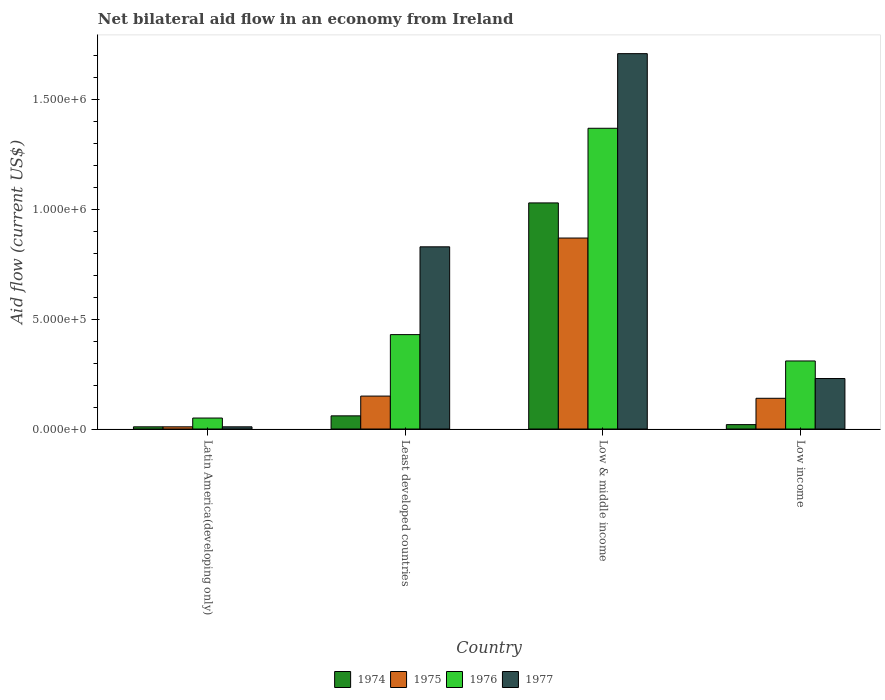Are the number of bars on each tick of the X-axis equal?
Your response must be concise. Yes. How many bars are there on the 2nd tick from the left?
Make the answer very short. 4. How many bars are there on the 1st tick from the right?
Your answer should be very brief. 4. Across all countries, what is the maximum net bilateral aid flow in 1976?
Provide a short and direct response. 1.37e+06. In which country was the net bilateral aid flow in 1977 maximum?
Provide a short and direct response. Low & middle income. In which country was the net bilateral aid flow in 1976 minimum?
Ensure brevity in your answer.  Latin America(developing only). What is the total net bilateral aid flow in 1976 in the graph?
Make the answer very short. 2.16e+06. What is the difference between the net bilateral aid flow in 1974 in Latin America(developing only) and that in Low income?
Offer a terse response. -10000. What is the average net bilateral aid flow in 1977 per country?
Provide a short and direct response. 6.95e+05. What is the ratio of the net bilateral aid flow in 1976 in Least developed countries to that in Low & middle income?
Your response must be concise. 0.31. Is the difference between the net bilateral aid flow in 1977 in Low & middle income and Low income greater than the difference between the net bilateral aid flow in 1976 in Low & middle income and Low income?
Ensure brevity in your answer.  Yes. What is the difference between the highest and the second highest net bilateral aid flow in 1976?
Your answer should be compact. 9.40e+05. What is the difference between the highest and the lowest net bilateral aid flow in 1975?
Provide a succinct answer. 8.60e+05. In how many countries, is the net bilateral aid flow in 1975 greater than the average net bilateral aid flow in 1975 taken over all countries?
Give a very brief answer. 1. Is the sum of the net bilateral aid flow in 1974 in Latin America(developing only) and Low & middle income greater than the maximum net bilateral aid flow in 1976 across all countries?
Offer a very short reply. No. What does the 4th bar from the left in Low & middle income represents?
Make the answer very short. 1977. What does the 4th bar from the right in Least developed countries represents?
Offer a terse response. 1974. Is it the case that in every country, the sum of the net bilateral aid flow in 1975 and net bilateral aid flow in 1974 is greater than the net bilateral aid flow in 1976?
Your response must be concise. No. What is the difference between two consecutive major ticks on the Y-axis?
Your answer should be very brief. 5.00e+05. Are the values on the major ticks of Y-axis written in scientific E-notation?
Make the answer very short. Yes. Does the graph contain any zero values?
Give a very brief answer. No. How many legend labels are there?
Offer a very short reply. 4. How are the legend labels stacked?
Provide a short and direct response. Horizontal. What is the title of the graph?
Your response must be concise. Net bilateral aid flow in an economy from Ireland. What is the Aid flow (current US$) of 1974 in Latin America(developing only)?
Your answer should be very brief. 10000. What is the Aid flow (current US$) of 1976 in Least developed countries?
Offer a very short reply. 4.30e+05. What is the Aid flow (current US$) of 1977 in Least developed countries?
Offer a terse response. 8.30e+05. What is the Aid flow (current US$) of 1974 in Low & middle income?
Offer a terse response. 1.03e+06. What is the Aid flow (current US$) in 1975 in Low & middle income?
Offer a very short reply. 8.70e+05. What is the Aid flow (current US$) in 1976 in Low & middle income?
Your response must be concise. 1.37e+06. What is the Aid flow (current US$) of 1977 in Low & middle income?
Your answer should be compact. 1.71e+06. What is the Aid flow (current US$) in 1974 in Low income?
Offer a very short reply. 2.00e+04. What is the Aid flow (current US$) in 1975 in Low income?
Your response must be concise. 1.40e+05. Across all countries, what is the maximum Aid flow (current US$) of 1974?
Offer a terse response. 1.03e+06. Across all countries, what is the maximum Aid flow (current US$) of 1975?
Provide a short and direct response. 8.70e+05. Across all countries, what is the maximum Aid flow (current US$) in 1976?
Your answer should be compact. 1.37e+06. Across all countries, what is the maximum Aid flow (current US$) in 1977?
Keep it short and to the point. 1.71e+06. Across all countries, what is the minimum Aid flow (current US$) in 1975?
Your response must be concise. 10000. What is the total Aid flow (current US$) in 1974 in the graph?
Offer a very short reply. 1.12e+06. What is the total Aid flow (current US$) of 1975 in the graph?
Offer a terse response. 1.17e+06. What is the total Aid flow (current US$) in 1976 in the graph?
Your answer should be compact. 2.16e+06. What is the total Aid flow (current US$) of 1977 in the graph?
Your answer should be very brief. 2.78e+06. What is the difference between the Aid flow (current US$) of 1975 in Latin America(developing only) and that in Least developed countries?
Offer a terse response. -1.40e+05. What is the difference between the Aid flow (current US$) of 1976 in Latin America(developing only) and that in Least developed countries?
Keep it short and to the point. -3.80e+05. What is the difference between the Aid flow (current US$) of 1977 in Latin America(developing only) and that in Least developed countries?
Offer a terse response. -8.20e+05. What is the difference between the Aid flow (current US$) in 1974 in Latin America(developing only) and that in Low & middle income?
Your answer should be very brief. -1.02e+06. What is the difference between the Aid flow (current US$) in 1975 in Latin America(developing only) and that in Low & middle income?
Ensure brevity in your answer.  -8.60e+05. What is the difference between the Aid flow (current US$) of 1976 in Latin America(developing only) and that in Low & middle income?
Your answer should be very brief. -1.32e+06. What is the difference between the Aid flow (current US$) in 1977 in Latin America(developing only) and that in Low & middle income?
Your response must be concise. -1.70e+06. What is the difference between the Aid flow (current US$) in 1975 in Latin America(developing only) and that in Low income?
Your response must be concise. -1.30e+05. What is the difference between the Aid flow (current US$) of 1976 in Latin America(developing only) and that in Low income?
Give a very brief answer. -2.60e+05. What is the difference between the Aid flow (current US$) in 1977 in Latin America(developing only) and that in Low income?
Offer a terse response. -2.20e+05. What is the difference between the Aid flow (current US$) in 1974 in Least developed countries and that in Low & middle income?
Your answer should be very brief. -9.70e+05. What is the difference between the Aid flow (current US$) in 1975 in Least developed countries and that in Low & middle income?
Your answer should be very brief. -7.20e+05. What is the difference between the Aid flow (current US$) in 1976 in Least developed countries and that in Low & middle income?
Give a very brief answer. -9.40e+05. What is the difference between the Aid flow (current US$) of 1977 in Least developed countries and that in Low & middle income?
Give a very brief answer. -8.80e+05. What is the difference between the Aid flow (current US$) of 1976 in Least developed countries and that in Low income?
Your answer should be compact. 1.20e+05. What is the difference between the Aid flow (current US$) of 1977 in Least developed countries and that in Low income?
Provide a succinct answer. 6.00e+05. What is the difference between the Aid flow (current US$) in 1974 in Low & middle income and that in Low income?
Your answer should be compact. 1.01e+06. What is the difference between the Aid flow (current US$) in 1975 in Low & middle income and that in Low income?
Offer a very short reply. 7.30e+05. What is the difference between the Aid flow (current US$) of 1976 in Low & middle income and that in Low income?
Provide a short and direct response. 1.06e+06. What is the difference between the Aid flow (current US$) of 1977 in Low & middle income and that in Low income?
Make the answer very short. 1.48e+06. What is the difference between the Aid flow (current US$) in 1974 in Latin America(developing only) and the Aid flow (current US$) in 1976 in Least developed countries?
Provide a short and direct response. -4.20e+05. What is the difference between the Aid flow (current US$) in 1974 in Latin America(developing only) and the Aid flow (current US$) in 1977 in Least developed countries?
Ensure brevity in your answer.  -8.20e+05. What is the difference between the Aid flow (current US$) of 1975 in Latin America(developing only) and the Aid flow (current US$) of 1976 in Least developed countries?
Keep it short and to the point. -4.20e+05. What is the difference between the Aid flow (current US$) of 1975 in Latin America(developing only) and the Aid flow (current US$) of 1977 in Least developed countries?
Provide a succinct answer. -8.20e+05. What is the difference between the Aid flow (current US$) in 1976 in Latin America(developing only) and the Aid flow (current US$) in 1977 in Least developed countries?
Make the answer very short. -7.80e+05. What is the difference between the Aid flow (current US$) of 1974 in Latin America(developing only) and the Aid flow (current US$) of 1975 in Low & middle income?
Your answer should be very brief. -8.60e+05. What is the difference between the Aid flow (current US$) in 1974 in Latin America(developing only) and the Aid flow (current US$) in 1976 in Low & middle income?
Give a very brief answer. -1.36e+06. What is the difference between the Aid flow (current US$) in 1974 in Latin America(developing only) and the Aid flow (current US$) in 1977 in Low & middle income?
Keep it short and to the point. -1.70e+06. What is the difference between the Aid flow (current US$) of 1975 in Latin America(developing only) and the Aid flow (current US$) of 1976 in Low & middle income?
Offer a very short reply. -1.36e+06. What is the difference between the Aid flow (current US$) in 1975 in Latin America(developing only) and the Aid flow (current US$) in 1977 in Low & middle income?
Ensure brevity in your answer.  -1.70e+06. What is the difference between the Aid flow (current US$) of 1976 in Latin America(developing only) and the Aid flow (current US$) of 1977 in Low & middle income?
Provide a short and direct response. -1.66e+06. What is the difference between the Aid flow (current US$) in 1974 in Latin America(developing only) and the Aid flow (current US$) in 1976 in Low income?
Make the answer very short. -3.00e+05. What is the difference between the Aid flow (current US$) in 1975 in Latin America(developing only) and the Aid flow (current US$) in 1977 in Low income?
Provide a succinct answer. -2.20e+05. What is the difference between the Aid flow (current US$) in 1976 in Latin America(developing only) and the Aid flow (current US$) in 1977 in Low income?
Provide a short and direct response. -1.80e+05. What is the difference between the Aid flow (current US$) in 1974 in Least developed countries and the Aid flow (current US$) in 1975 in Low & middle income?
Provide a short and direct response. -8.10e+05. What is the difference between the Aid flow (current US$) in 1974 in Least developed countries and the Aid flow (current US$) in 1976 in Low & middle income?
Keep it short and to the point. -1.31e+06. What is the difference between the Aid flow (current US$) in 1974 in Least developed countries and the Aid flow (current US$) in 1977 in Low & middle income?
Your answer should be compact. -1.65e+06. What is the difference between the Aid flow (current US$) in 1975 in Least developed countries and the Aid flow (current US$) in 1976 in Low & middle income?
Make the answer very short. -1.22e+06. What is the difference between the Aid flow (current US$) of 1975 in Least developed countries and the Aid flow (current US$) of 1977 in Low & middle income?
Offer a terse response. -1.56e+06. What is the difference between the Aid flow (current US$) of 1976 in Least developed countries and the Aid flow (current US$) of 1977 in Low & middle income?
Keep it short and to the point. -1.28e+06. What is the difference between the Aid flow (current US$) of 1974 in Least developed countries and the Aid flow (current US$) of 1977 in Low income?
Provide a succinct answer. -1.70e+05. What is the difference between the Aid flow (current US$) of 1975 in Least developed countries and the Aid flow (current US$) of 1976 in Low income?
Keep it short and to the point. -1.60e+05. What is the difference between the Aid flow (current US$) in 1974 in Low & middle income and the Aid flow (current US$) in 1975 in Low income?
Offer a terse response. 8.90e+05. What is the difference between the Aid flow (current US$) in 1974 in Low & middle income and the Aid flow (current US$) in 1976 in Low income?
Offer a terse response. 7.20e+05. What is the difference between the Aid flow (current US$) in 1975 in Low & middle income and the Aid flow (current US$) in 1976 in Low income?
Your response must be concise. 5.60e+05. What is the difference between the Aid flow (current US$) of 1975 in Low & middle income and the Aid flow (current US$) of 1977 in Low income?
Your response must be concise. 6.40e+05. What is the difference between the Aid flow (current US$) in 1976 in Low & middle income and the Aid flow (current US$) in 1977 in Low income?
Make the answer very short. 1.14e+06. What is the average Aid flow (current US$) of 1975 per country?
Ensure brevity in your answer.  2.92e+05. What is the average Aid flow (current US$) of 1976 per country?
Your answer should be compact. 5.40e+05. What is the average Aid flow (current US$) of 1977 per country?
Keep it short and to the point. 6.95e+05. What is the difference between the Aid flow (current US$) in 1974 and Aid flow (current US$) in 1975 in Latin America(developing only)?
Make the answer very short. 0. What is the difference between the Aid flow (current US$) in 1974 and Aid flow (current US$) in 1976 in Latin America(developing only)?
Offer a very short reply. -4.00e+04. What is the difference between the Aid flow (current US$) in 1975 and Aid flow (current US$) in 1976 in Latin America(developing only)?
Your answer should be compact. -4.00e+04. What is the difference between the Aid flow (current US$) of 1975 and Aid flow (current US$) of 1977 in Latin America(developing only)?
Make the answer very short. 0. What is the difference between the Aid flow (current US$) in 1976 and Aid flow (current US$) in 1977 in Latin America(developing only)?
Offer a very short reply. 4.00e+04. What is the difference between the Aid flow (current US$) of 1974 and Aid flow (current US$) of 1975 in Least developed countries?
Your answer should be very brief. -9.00e+04. What is the difference between the Aid flow (current US$) in 1974 and Aid flow (current US$) in 1976 in Least developed countries?
Ensure brevity in your answer.  -3.70e+05. What is the difference between the Aid flow (current US$) of 1974 and Aid flow (current US$) of 1977 in Least developed countries?
Keep it short and to the point. -7.70e+05. What is the difference between the Aid flow (current US$) in 1975 and Aid flow (current US$) in 1976 in Least developed countries?
Provide a short and direct response. -2.80e+05. What is the difference between the Aid flow (current US$) in 1975 and Aid flow (current US$) in 1977 in Least developed countries?
Provide a succinct answer. -6.80e+05. What is the difference between the Aid flow (current US$) of 1976 and Aid flow (current US$) of 1977 in Least developed countries?
Your answer should be compact. -4.00e+05. What is the difference between the Aid flow (current US$) of 1974 and Aid flow (current US$) of 1976 in Low & middle income?
Your response must be concise. -3.40e+05. What is the difference between the Aid flow (current US$) of 1974 and Aid flow (current US$) of 1977 in Low & middle income?
Offer a very short reply. -6.80e+05. What is the difference between the Aid flow (current US$) in 1975 and Aid flow (current US$) in 1976 in Low & middle income?
Keep it short and to the point. -5.00e+05. What is the difference between the Aid flow (current US$) in 1975 and Aid flow (current US$) in 1977 in Low & middle income?
Ensure brevity in your answer.  -8.40e+05. What is the difference between the Aid flow (current US$) of 1974 and Aid flow (current US$) of 1975 in Low income?
Provide a short and direct response. -1.20e+05. What is the difference between the Aid flow (current US$) of 1974 and Aid flow (current US$) of 1977 in Low income?
Offer a terse response. -2.10e+05. What is the difference between the Aid flow (current US$) of 1975 and Aid flow (current US$) of 1977 in Low income?
Offer a terse response. -9.00e+04. What is the difference between the Aid flow (current US$) in 1976 and Aid flow (current US$) in 1977 in Low income?
Make the answer very short. 8.00e+04. What is the ratio of the Aid flow (current US$) in 1975 in Latin America(developing only) to that in Least developed countries?
Keep it short and to the point. 0.07. What is the ratio of the Aid flow (current US$) in 1976 in Latin America(developing only) to that in Least developed countries?
Your answer should be compact. 0.12. What is the ratio of the Aid flow (current US$) of 1977 in Latin America(developing only) to that in Least developed countries?
Make the answer very short. 0.01. What is the ratio of the Aid flow (current US$) of 1974 in Latin America(developing only) to that in Low & middle income?
Your answer should be very brief. 0.01. What is the ratio of the Aid flow (current US$) in 1975 in Latin America(developing only) to that in Low & middle income?
Provide a succinct answer. 0.01. What is the ratio of the Aid flow (current US$) of 1976 in Latin America(developing only) to that in Low & middle income?
Offer a terse response. 0.04. What is the ratio of the Aid flow (current US$) of 1977 in Latin America(developing only) to that in Low & middle income?
Provide a short and direct response. 0.01. What is the ratio of the Aid flow (current US$) in 1975 in Latin America(developing only) to that in Low income?
Your answer should be very brief. 0.07. What is the ratio of the Aid flow (current US$) of 1976 in Latin America(developing only) to that in Low income?
Offer a terse response. 0.16. What is the ratio of the Aid flow (current US$) of 1977 in Latin America(developing only) to that in Low income?
Your answer should be very brief. 0.04. What is the ratio of the Aid flow (current US$) in 1974 in Least developed countries to that in Low & middle income?
Make the answer very short. 0.06. What is the ratio of the Aid flow (current US$) in 1975 in Least developed countries to that in Low & middle income?
Offer a terse response. 0.17. What is the ratio of the Aid flow (current US$) of 1976 in Least developed countries to that in Low & middle income?
Offer a very short reply. 0.31. What is the ratio of the Aid flow (current US$) in 1977 in Least developed countries to that in Low & middle income?
Your response must be concise. 0.49. What is the ratio of the Aid flow (current US$) of 1974 in Least developed countries to that in Low income?
Provide a succinct answer. 3. What is the ratio of the Aid flow (current US$) of 1975 in Least developed countries to that in Low income?
Your answer should be compact. 1.07. What is the ratio of the Aid flow (current US$) of 1976 in Least developed countries to that in Low income?
Your answer should be very brief. 1.39. What is the ratio of the Aid flow (current US$) in 1977 in Least developed countries to that in Low income?
Offer a very short reply. 3.61. What is the ratio of the Aid flow (current US$) of 1974 in Low & middle income to that in Low income?
Your response must be concise. 51.5. What is the ratio of the Aid flow (current US$) in 1975 in Low & middle income to that in Low income?
Give a very brief answer. 6.21. What is the ratio of the Aid flow (current US$) in 1976 in Low & middle income to that in Low income?
Offer a very short reply. 4.42. What is the ratio of the Aid flow (current US$) in 1977 in Low & middle income to that in Low income?
Ensure brevity in your answer.  7.43. What is the difference between the highest and the second highest Aid flow (current US$) of 1974?
Give a very brief answer. 9.70e+05. What is the difference between the highest and the second highest Aid flow (current US$) of 1975?
Keep it short and to the point. 7.20e+05. What is the difference between the highest and the second highest Aid flow (current US$) in 1976?
Your answer should be very brief. 9.40e+05. What is the difference between the highest and the second highest Aid flow (current US$) in 1977?
Ensure brevity in your answer.  8.80e+05. What is the difference between the highest and the lowest Aid flow (current US$) in 1974?
Offer a terse response. 1.02e+06. What is the difference between the highest and the lowest Aid flow (current US$) in 1975?
Ensure brevity in your answer.  8.60e+05. What is the difference between the highest and the lowest Aid flow (current US$) of 1976?
Offer a terse response. 1.32e+06. What is the difference between the highest and the lowest Aid flow (current US$) in 1977?
Your answer should be very brief. 1.70e+06. 